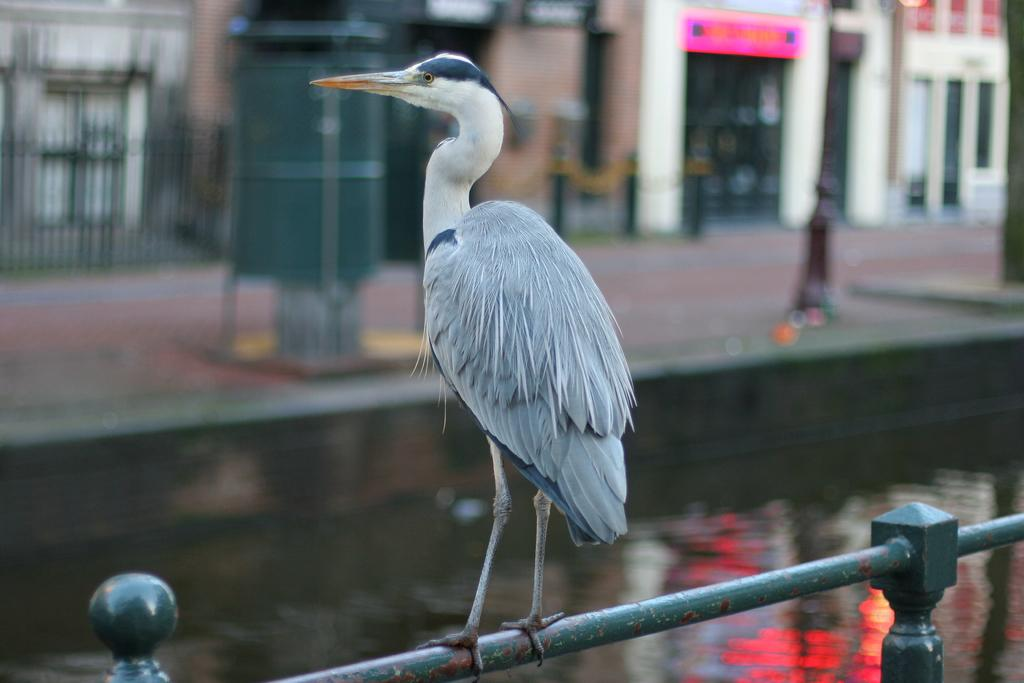What is the main subject of the image? There is a crane in the image. How is the crane positioned in the image? The crane is standing on a rod. What can be seen in the background of the image? There is water and buildings visible in the background of the image. How is the background of the image depicted? The background is blurred. What type of baseball is being played in the image? There is no baseball or any sports activity depicted in the image; it features a crane standing on a rod with a blurred background. 